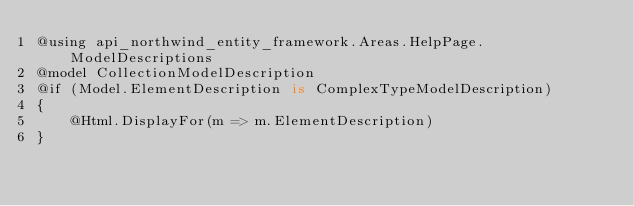<code> <loc_0><loc_0><loc_500><loc_500><_C#_>@using api_northwind_entity_framework.Areas.HelpPage.ModelDescriptions
@model CollectionModelDescription
@if (Model.ElementDescription is ComplexTypeModelDescription)
{
    @Html.DisplayFor(m => m.ElementDescription)
}</code> 